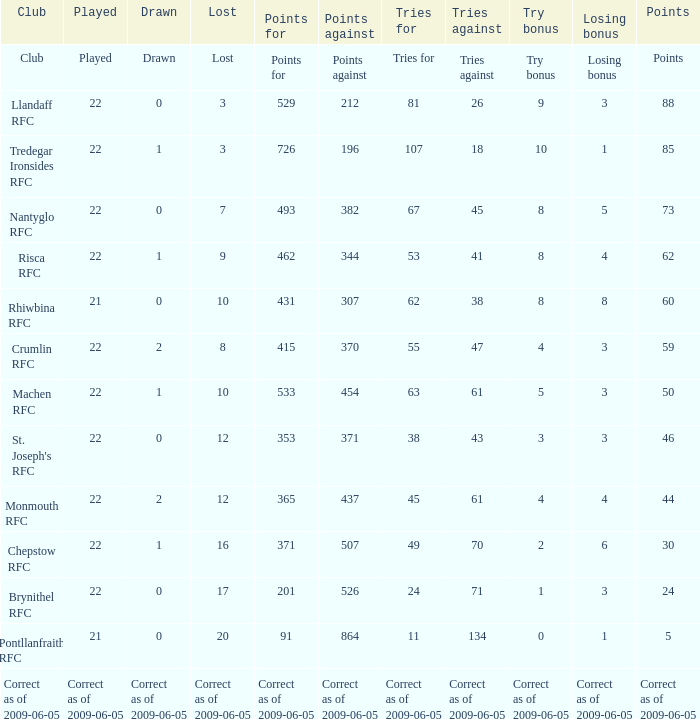If the Played was played, what is the lost? Lost. 